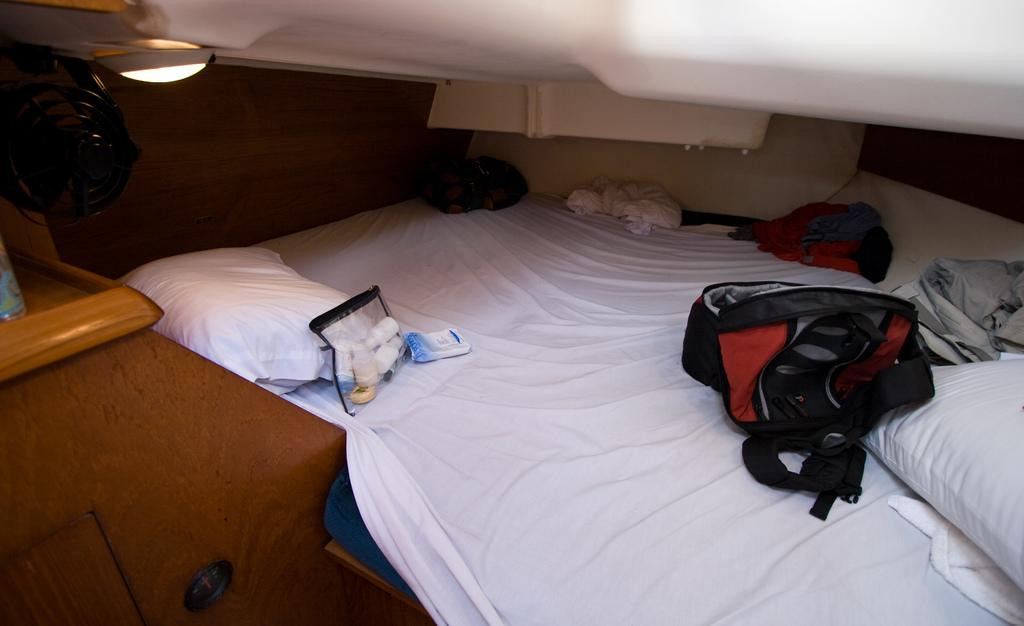What items are on the bed in the image? There are bags, pillows, and clothes on the bed. Can you describe the bed's surroundings? There is a light on the left side of the image. What type of hydrant is visible in the image? There is no hydrant present in the image. What color is the mouth of the person in the image? There is no person present in the image, so there is no mouth to describe. 